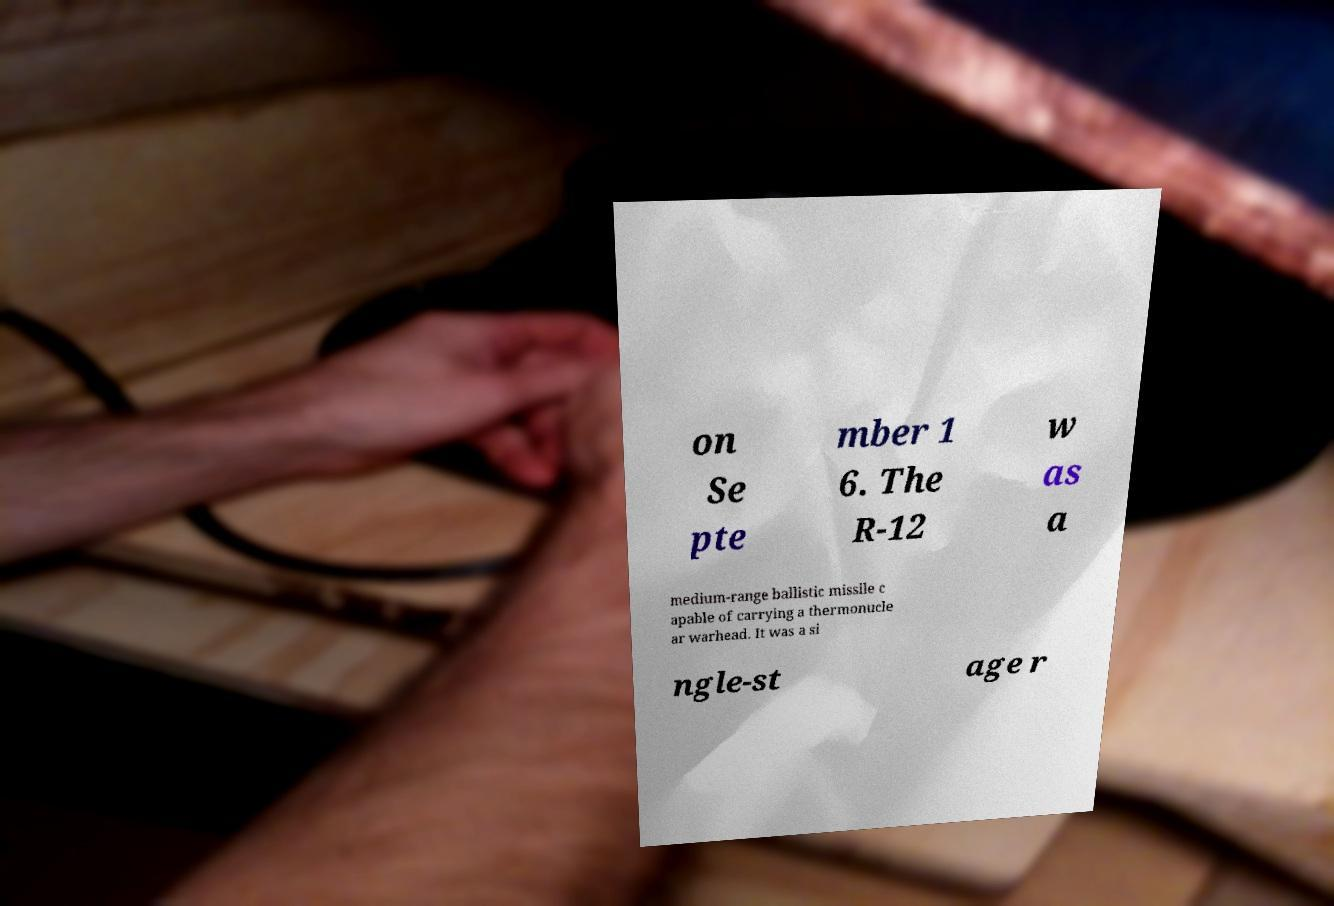For documentation purposes, I need the text within this image transcribed. Could you provide that? on Se pte mber 1 6. The R-12 w as a medium-range ballistic missile c apable of carrying a thermonucle ar warhead. It was a si ngle-st age r 